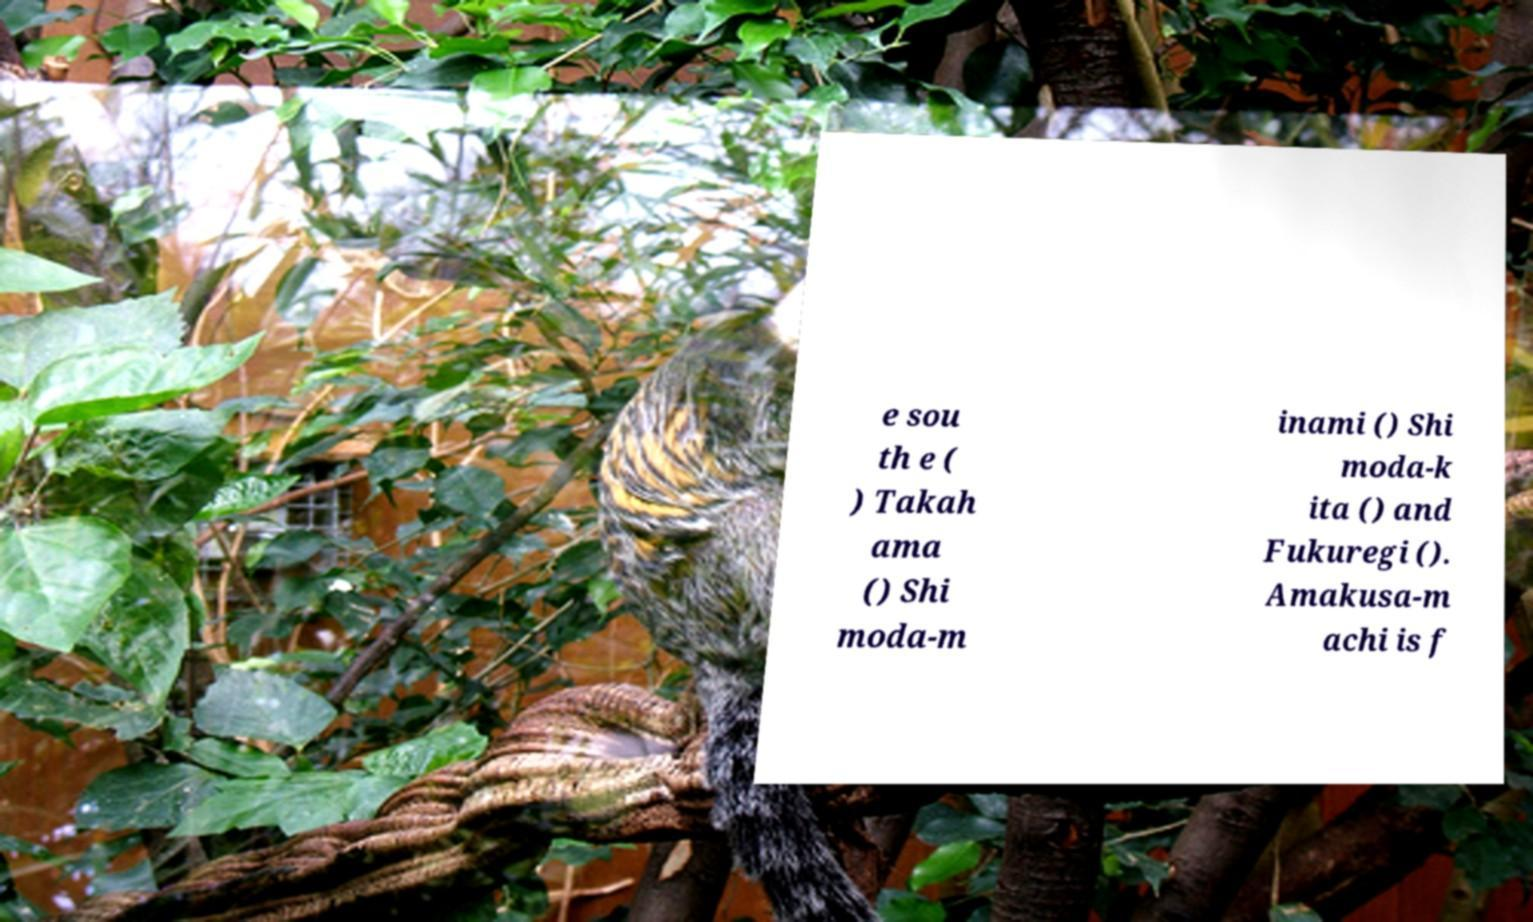For documentation purposes, I need the text within this image transcribed. Could you provide that? e sou th e ( ) Takah ama () Shi moda-m inami () Shi moda-k ita () and Fukuregi (). Amakusa-m achi is f 